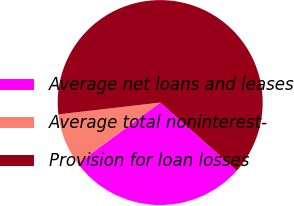Convert chart. <chart><loc_0><loc_0><loc_500><loc_500><pie_chart><fcel>Average net loans and leases<fcel>Average total noninterest-<fcel>Provision for loan losses<nl><fcel>28.3%<fcel>8.3%<fcel>63.41%<nl></chart> 